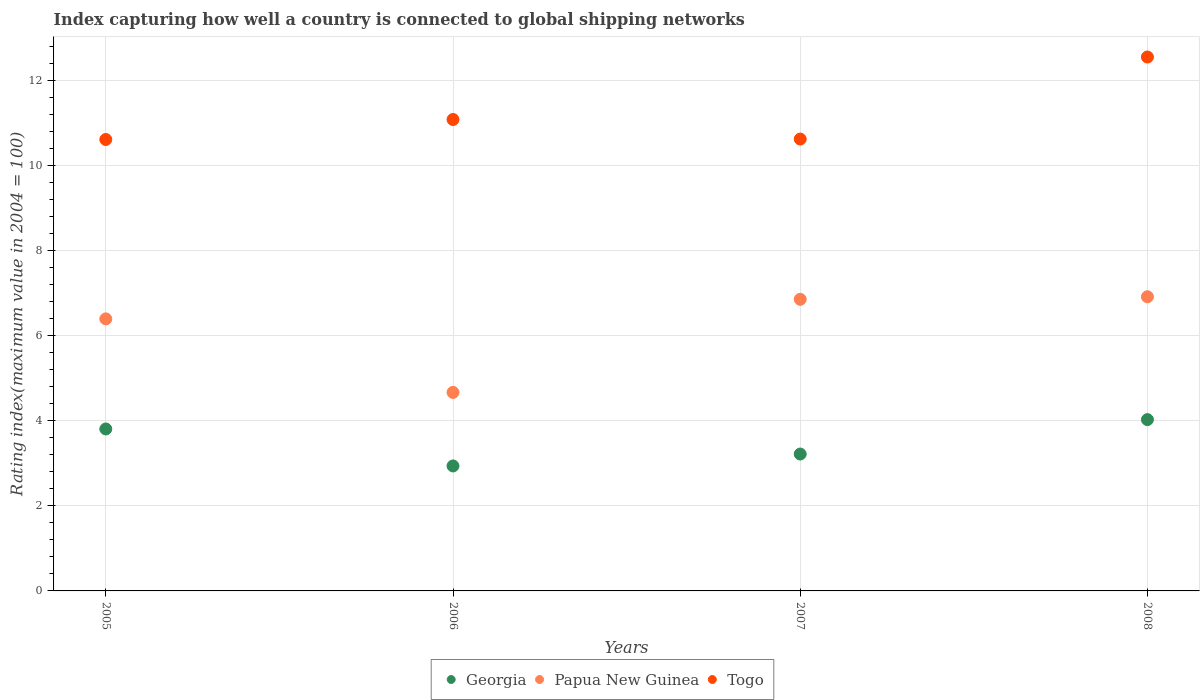Is the number of dotlines equal to the number of legend labels?
Your answer should be very brief. Yes. What is the rating index in Togo in 2007?
Keep it short and to the point. 10.63. Across all years, what is the maximum rating index in Togo?
Keep it short and to the point. 12.56. Across all years, what is the minimum rating index in Georgia?
Provide a succinct answer. 2.94. What is the total rating index in Togo in the graph?
Keep it short and to the point. 44.9. What is the difference between the rating index in Papua New Guinea in 2005 and that in 2007?
Your response must be concise. -0.46. What is the difference between the rating index in Papua New Guinea in 2005 and the rating index in Togo in 2008?
Your answer should be compact. -6.16. What is the average rating index in Papua New Guinea per year?
Provide a short and direct response. 6.21. In the year 2005, what is the difference between the rating index in Georgia and rating index in Togo?
Give a very brief answer. -6.81. What is the ratio of the rating index in Togo in 2005 to that in 2007?
Provide a succinct answer. 1. Is the rating index in Georgia in 2005 less than that in 2006?
Ensure brevity in your answer.  No. Is the difference between the rating index in Georgia in 2006 and 2007 greater than the difference between the rating index in Togo in 2006 and 2007?
Offer a terse response. No. What is the difference between the highest and the second highest rating index in Togo?
Ensure brevity in your answer.  1.47. What is the difference between the highest and the lowest rating index in Papua New Guinea?
Your answer should be compact. 2.25. In how many years, is the rating index in Papua New Guinea greater than the average rating index in Papua New Guinea taken over all years?
Keep it short and to the point. 3. Is it the case that in every year, the sum of the rating index in Papua New Guinea and rating index in Georgia  is greater than the rating index in Togo?
Your response must be concise. No. Is the rating index in Georgia strictly greater than the rating index in Papua New Guinea over the years?
Provide a short and direct response. No. Is the rating index in Papua New Guinea strictly less than the rating index in Georgia over the years?
Ensure brevity in your answer.  No. How many dotlines are there?
Your answer should be very brief. 3. How many years are there in the graph?
Provide a succinct answer. 4. What is the difference between two consecutive major ticks on the Y-axis?
Ensure brevity in your answer.  2. Are the values on the major ticks of Y-axis written in scientific E-notation?
Your response must be concise. No. Does the graph contain any zero values?
Your answer should be very brief. No. Where does the legend appear in the graph?
Make the answer very short. Bottom center. How are the legend labels stacked?
Your answer should be compact. Horizontal. What is the title of the graph?
Provide a short and direct response. Index capturing how well a country is connected to global shipping networks. Does "Switzerland" appear as one of the legend labels in the graph?
Give a very brief answer. No. What is the label or title of the X-axis?
Your answer should be compact. Years. What is the label or title of the Y-axis?
Offer a very short reply. Rating index(maximum value in 2004 = 100). What is the Rating index(maximum value in 2004 = 100) of Georgia in 2005?
Offer a very short reply. 3.81. What is the Rating index(maximum value in 2004 = 100) in Papua New Guinea in 2005?
Offer a terse response. 6.4. What is the Rating index(maximum value in 2004 = 100) in Togo in 2005?
Give a very brief answer. 10.62. What is the Rating index(maximum value in 2004 = 100) of Georgia in 2006?
Your answer should be compact. 2.94. What is the Rating index(maximum value in 2004 = 100) of Papua New Guinea in 2006?
Offer a very short reply. 4.67. What is the Rating index(maximum value in 2004 = 100) of Togo in 2006?
Your answer should be very brief. 11.09. What is the Rating index(maximum value in 2004 = 100) in Georgia in 2007?
Offer a terse response. 3.22. What is the Rating index(maximum value in 2004 = 100) of Papua New Guinea in 2007?
Ensure brevity in your answer.  6.86. What is the Rating index(maximum value in 2004 = 100) of Togo in 2007?
Keep it short and to the point. 10.63. What is the Rating index(maximum value in 2004 = 100) in Georgia in 2008?
Provide a short and direct response. 4.03. What is the Rating index(maximum value in 2004 = 100) of Papua New Guinea in 2008?
Your answer should be compact. 6.92. What is the Rating index(maximum value in 2004 = 100) of Togo in 2008?
Give a very brief answer. 12.56. Across all years, what is the maximum Rating index(maximum value in 2004 = 100) of Georgia?
Offer a terse response. 4.03. Across all years, what is the maximum Rating index(maximum value in 2004 = 100) of Papua New Guinea?
Ensure brevity in your answer.  6.92. Across all years, what is the maximum Rating index(maximum value in 2004 = 100) in Togo?
Ensure brevity in your answer.  12.56. Across all years, what is the minimum Rating index(maximum value in 2004 = 100) in Georgia?
Your answer should be compact. 2.94. Across all years, what is the minimum Rating index(maximum value in 2004 = 100) in Papua New Guinea?
Provide a short and direct response. 4.67. Across all years, what is the minimum Rating index(maximum value in 2004 = 100) in Togo?
Offer a very short reply. 10.62. What is the total Rating index(maximum value in 2004 = 100) of Papua New Guinea in the graph?
Offer a terse response. 24.85. What is the total Rating index(maximum value in 2004 = 100) in Togo in the graph?
Your answer should be compact. 44.9. What is the difference between the Rating index(maximum value in 2004 = 100) of Georgia in 2005 and that in 2006?
Ensure brevity in your answer.  0.87. What is the difference between the Rating index(maximum value in 2004 = 100) in Papua New Guinea in 2005 and that in 2006?
Your answer should be compact. 1.73. What is the difference between the Rating index(maximum value in 2004 = 100) in Togo in 2005 and that in 2006?
Ensure brevity in your answer.  -0.47. What is the difference between the Rating index(maximum value in 2004 = 100) of Georgia in 2005 and that in 2007?
Your answer should be compact. 0.59. What is the difference between the Rating index(maximum value in 2004 = 100) in Papua New Guinea in 2005 and that in 2007?
Your response must be concise. -0.46. What is the difference between the Rating index(maximum value in 2004 = 100) of Togo in 2005 and that in 2007?
Your response must be concise. -0.01. What is the difference between the Rating index(maximum value in 2004 = 100) in Georgia in 2005 and that in 2008?
Your answer should be compact. -0.22. What is the difference between the Rating index(maximum value in 2004 = 100) of Papua New Guinea in 2005 and that in 2008?
Your answer should be compact. -0.52. What is the difference between the Rating index(maximum value in 2004 = 100) of Togo in 2005 and that in 2008?
Ensure brevity in your answer.  -1.94. What is the difference between the Rating index(maximum value in 2004 = 100) of Georgia in 2006 and that in 2007?
Your response must be concise. -0.28. What is the difference between the Rating index(maximum value in 2004 = 100) in Papua New Guinea in 2006 and that in 2007?
Give a very brief answer. -2.19. What is the difference between the Rating index(maximum value in 2004 = 100) in Togo in 2006 and that in 2007?
Offer a very short reply. 0.46. What is the difference between the Rating index(maximum value in 2004 = 100) of Georgia in 2006 and that in 2008?
Offer a very short reply. -1.09. What is the difference between the Rating index(maximum value in 2004 = 100) of Papua New Guinea in 2006 and that in 2008?
Provide a succinct answer. -2.25. What is the difference between the Rating index(maximum value in 2004 = 100) in Togo in 2006 and that in 2008?
Your answer should be very brief. -1.47. What is the difference between the Rating index(maximum value in 2004 = 100) of Georgia in 2007 and that in 2008?
Provide a succinct answer. -0.81. What is the difference between the Rating index(maximum value in 2004 = 100) in Papua New Guinea in 2007 and that in 2008?
Provide a short and direct response. -0.06. What is the difference between the Rating index(maximum value in 2004 = 100) of Togo in 2007 and that in 2008?
Ensure brevity in your answer.  -1.93. What is the difference between the Rating index(maximum value in 2004 = 100) in Georgia in 2005 and the Rating index(maximum value in 2004 = 100) in Papua New Guinea in 2006?
Offer a terse response. -0.86. What is the difference between the Rating index(maximum value in 2004 = 100) in Georgia in 2005 and the Rating index(maximum value in 2004 = 100) in Togo in 2006?
Offer a very short reply. -7.28. What is the difference between the Rating index(maximum value in 2004 = 100) of Papua New Guinea in 2005 and the Rating index(maximum value in 2004 = 100) of Togo in 2006?
Keep it short and to the point. -4.69. What is the difference between the Rating index(maximum value in 2004 = 100) of Georgia in 2005 and the Rating index(maximum value in 2004 = 100) of Papua New Guinea in 2007?
Your answer should be very brief. -3.05. What is the difference between the Rating index(maximum value in 2004 = 100) of Georgia in 2005 and the Rating index(maximum value in 2004 = 100) of Togo in 2007?
Provide a short and direct response. -6.82. What is the difference between the Rating index(maximum value in 2004 = 100) in Papua New Guinea in 2005 and the Rating index(maximum value in 2004 = 100) in Togo in 2007?
Make the answer very short. -4.23. What is the difference between the Rating index(maximum value in 2004 = 100) of Georgia in 2005 and the Rating index(maximum value in 2004 = 100) of Papua New Guinea in 2008?
Offer a terse response. -3.11. What is the difference between the Rating index(maximum value in 2004 = 100) of Georgia in 2005 and the Rating index(maximum value in 2004 = 100) of Togo in 2008?
Provide a short and direct response. -8.75. What is the difference between the Rating index(maximum value in 2004 = 100) in Papua New Guinea in 2005 and the Rating index(maximum value in 2004 = 100) in Togo in 2008?
Your answer should be compact. -6.16. What is the difference between the Rating index(maximum value in 2004 = 100) of Georgia in 2006 and the Rating index(maximum value in 2004 = 100) of Papua New Guinea in 2007?
Your answer should be very brief. -3.92. What is the difference between the Rating index(maximum value in 2004 = 100) of Georgia in 2006 and the Rating index(maximum value in 2004 = 100) of Togo in 2007?
Provide a succinct answer. -7.69. What is the difference between the Rating index(maximum value in 2004 = 100) of Papua New Guinea in 2006 and the Rating index(maximum value in 2004 = 100) of Togo in 2007?
Provide a succinct answer. -5.96. What is the difference between the Rating index(maximum value in 2004 = 100) in Georgia in 2006 and the Rating index(maximum value in 2004 = 100) in Papua New Guinea in 2008?
Offer a very short reply. -3.98. What is the difference between the Rating index(maximum value in 2004 = 100) of Georgia in 2006 and the Rating index(maximum value in 2004 = 100) of Togo in 2008?
Offer a very short reply. -9.62. What is the difference between the Rating index(maximum value in 2004 = 100) in Papua New Guinea in 2006 and the Rating index(maximum value in 2004 = 100) in Togo in 2008?
Provide a short and direct response. -7.89. What is the difference between the Rating index(maximum value in 2004 = 100) in Georgia in 2007 and the Rating index(maximum value in 2004 = 100) in Papua New Guinea in 2008?
Your answer should be very brief. -3.7. What is the difference between the Rating index(maximum value in 2004 = 100) of Georgia in 2007 and the Rating index(maximum value in 2004 = 100) of Togo in 2008?
Make the answer very short. -9.34. What is the average Rating index(maximum value in 2004 = 100) in Papua New Guinea per year?
Your response must be concise. 6.21. What is the average Rating index(maximum value in 2004 = 100) of Togo per year?
Provide a short and direct response. 11.22. In the year 2005, what is the difference between the Rating index(maximum value in 2004 = 100) of Georgia and Rating index(maximum value in 2004 = 100) of Papua New Guinea?
Your response must be concise. -2.59. In the year 2005, what is the difference between the Rating index(maximum value in 2004 = 100) of Georgia and Rating index(maximum value in 2004 = 100) of Togo?
Provide a short and direct response. -6.81. In the year 2005, what is the difference between the Rating index(maximum value in 2004 = 100) in Papua New Guinea and Rating index(maximum value in 2004 = 100) in Togo?
Keep it short and to the point. -4.22. In the year 2006, what is the difference between the Rating index(maximum value in 2004 = 100) of Georgia and Rating index(maximum value in 2004 = 100) of Papua New Guinea?
Your answer should be very brief. -1.73. In the year 2006, what is the difference between the Rating index(maximum value in 2004 = 100) of Georgia and Rating index(maximum value in 2004 = 100) of Togo?
Your answer should be compact. -8.15. In the year 2006, what is the difference between the Rating index(maximum value in 2004 = 100) in Papua New Guinea and Rating index(maximum value in 2004 = 100) in Togo?
Your answer should be very brief. -6.42. In the year 2007, what is the difference between the Rating index(maximum value in 2004 = 100) in Georgia and Rating index(maximum value in 2004 = 100) in Papua New Guinea?
Offer a terse response. -3.64. In the year 2007, what is the difference between the Rating index(maximum value in 2004 = 100) of Georgia and Rating index(maximum value in 2004 = 100) of Togo?
Provide a succinct answer. -7.41. In the year 2007, what is the difference between the Rating index(maximum value in 2004 = 100) of Papua New Guinea and Rating index(maximum value in 2004 = 100) of Togo?
Your response must be concise. -3.77. In the year 2008, what is the difference between the Rating index(maximum value in 2004 = 100) of Georgia and Rating index(maximum value in 2004 = 100) of Papua New Guinea?
Make the answer very short. -2.89. In the year 2008, what is the difference between the Rating index(maximum value in 2004 = 100) of Georgia and Rating index(maximum value in 2004 = 100) of Togo?
Keep it short and to the point. -8.53. In the year 2008, what is the difference between the Rating index(maximum value in 2004 = 100) of Papua New Guinea and Rating index(maximum value in 2004 = 100) of Togo?
Provide a short and direct response. -5.64. What is the ratio of the Rating index(maximum value in 2004 = 100) of Georgia in 2005 to that in 2006?
Ensure brevity in your answer.  1.3. What is the ratio of the Rating index(maximum value in 2004 = 100) of Papua New Guinea in 2005 to that in 2006?
Your answer should be compact. 1.37. What is the ratio of the Rating index(maximum value in 2004 = 100) in Togo in 2005 to that in 2006?
Your answer should be very brief. 0.96. What is the ratio of the Rating index(maximum value in 2004 = 100) in Georgia in 2005 to that in 2007?
Your answer should be very brief. 1.18. What is the ratio of the Rating index(maximum value in 2004 = 100) of Papua New Guinea in 2005 to that in 2007?
Keep it short and to the point. 0.93. What is the ratio of the Rating index(maximum value in 2004 = 100) in Georgia in 2005 to that in 2008?
Make the answer very short. 0.95. What is the ratio of the Rating index(maximum value in 2004 = 100) of Papua New Guinea in 2005 to that in 2008?
Provide a short and direct response. 0.92. What is the ratio of the Rating index(maximum value in 2004 = 100) of Togo in 2005 to that in 2008?
Provide a succinct answer. 0.85. What is the ratio of the Rating index(maximum value in 2004 = 100) of Papua New Guinea in 2006 to that in 2007?
Make the answer very short. 0.68. What is the ratio of the Rating index(maximum value in 2004 = 100) in Togo in 2006 to that in 2007?
Make the answer very short. 1.04. What is the ratio of the Rating index(maximum value in 2004 = 100) in Georgia in 2006 to that in 2008?
Your answer should be very brief. 0.73. What is the ratio of the Rating index(maximum value in 2004 = 100) of Papua New Guinea in 2006 to that in 2008?
Your answer should be very brief. 0.67. What is the ratio of the Rating index(maximum value in 2004 = 100) in Togo in 2006 to that in 2008?
Provide a succinct answer. 0.88. What is the ratio of the Rating index(maximum value in 2004 = 100) in Georgia in 2007 to that in 2008?
Provide a short and direct response. 0.8. What is the ratio of the Rating index(maximum value in 2004 = 100) of Togo in 2007 to that in 2008?
Give a very brief answer. 0.85. What is the difference between the highest and the second highest Rating index(maximum value in 2004 = 100) of Georgia?
Your response must be concise. 0.22. What is the difference between the highest and the second highest Rating index(maximum value in 2004 = 100) in Papua New Guinea?
Offer a very short reply. 0.06. What is the difference between the highest and the second highest Rating index(maximum value in 2004 = 100) of Togo?
Provide a short and direct response. 1.47. What is the difference between the highest and the lowest Rating index(maximum value in 2004 = 100) in Georgia?
Make the answer very short. 1.09. What is the difference between the highest and the lowest Rating index(maximum value in 2004 = 100) in Papua New Guinea?
Make the answer very short. 2.25. What is the difference between the highest and the lowest Rating index(maximum value in 2004 = 100) in Togo?
Provide a short and direct response. 1.94. 